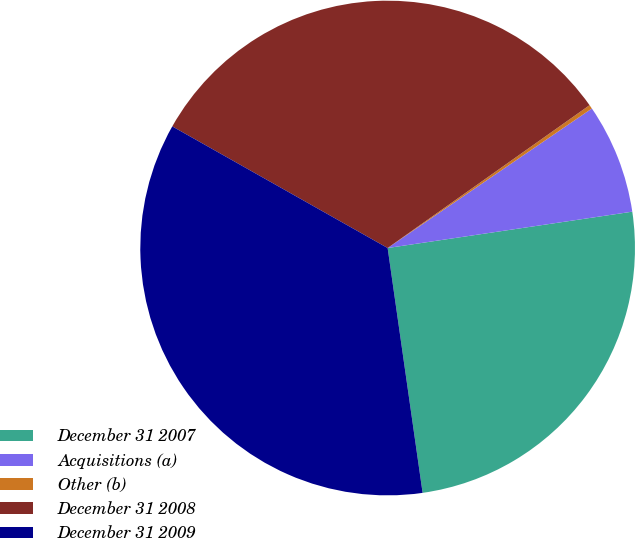Convert chart. <chart><loc_0><loc_0><loc_500><loc_500><pie_chart><fcel>December 31 2007<fcel>Acquisitions (a)<fcel>Other (b)<fcel>December 31 2008<fcel>December 31 2009<nl><fcel>25.09%<fcel>7.19%<fcel>0.26%<fcel>32.02%<fcel>35.44%<nl></chart> 